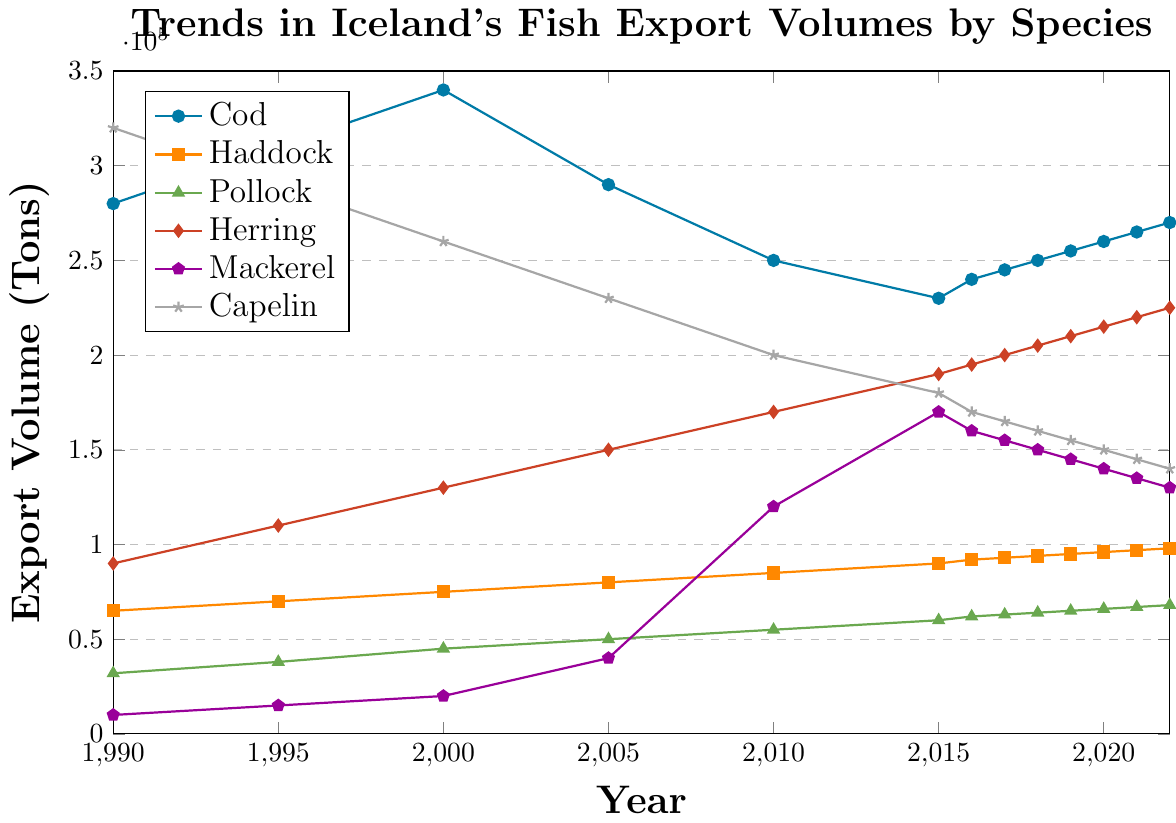What is the trend for Cod exports from 1990 to 2022? The line chart shows a general decline in export volume for Cod from 1990 to 2015, after which there is a gradual increase till 2022. Specifically, Cod exports decrease from 280,000 tons in 1990 to 230,000 tons in 2015, and then rise up to 270,000 tons in 2022.
Answer: General decline followed by a gradual increase Which year had the highest export volume for Capelin? By inspecting the line representing Capelin in the chart, we see that 1990 had the highest export volume at 320,000 tons. The volume for Capelin consistently declines after this peak.
Answer: 1990 Compare the export trends for Herring and Mackerel from 2000 onward. From the year 2000, the export volumes of Herring show a steady increase from 130,000 tons to 225,000 tons in 2022. On the other hand, Mackerel shows a sharp increase until 2015 peaking at 170,000 tons, followed by a decline to 130,000 tons in 2022.
Answer: Herring steadily increases while Mackerel first increases then declines What is the average export volume of Haddock from 2015 to 2022? The export volumes of Haddock from 2015 to 2022 are 90,000, 92,000, 93,000, 94,000, 95,000, 96,000, 97,000, and 98,000 tons. The average is calculated as (90,000 + 92,000 + 93,000 + 94,000 + 95,000 + 96,000 + 97,000 + 98,000) / 8 = 93,125 tons.
Answer: 93,125 tons Which species had the most dramatic change in export volume between any two consecutive years, and in what year? By examining the chart lines, Mackerel shows the most dramatic change between 2005 and 2010, where the export volume jumps from 40,000 tons to 120,000 tons, an increase of 80,000 tons.
Answer: Mackerel, 2005-2010 What was the difference in Pollock exports between 1995 and 2022? Observing the Pollock line, the export volume in 1995 is 38,000 tons and in 2022 it is 68,000 tons. The difference is 68,000 - 38,000 = 30,000 tons.
Answer: 30,000 tons Which species had a consistent increase in export volume from 1990 to 2022 without any year showing a decrease? Among all lines, only Herring demonstrates a consistent increase in export volume, starting from 90,000 tons in 1990 and ending at 225,000 tons in 2022, with no years showing a decrease.
Answer: Herring What was the combined export volume of Cod and Haddock in 2022? From the chart, the export volumes in 2022 for Cod and Haddock are 270,000 and 98,000 tons respectively. The combined volume is 270,000 + 98,000 = 368,000 tons.
Answer: 368,000 tons 